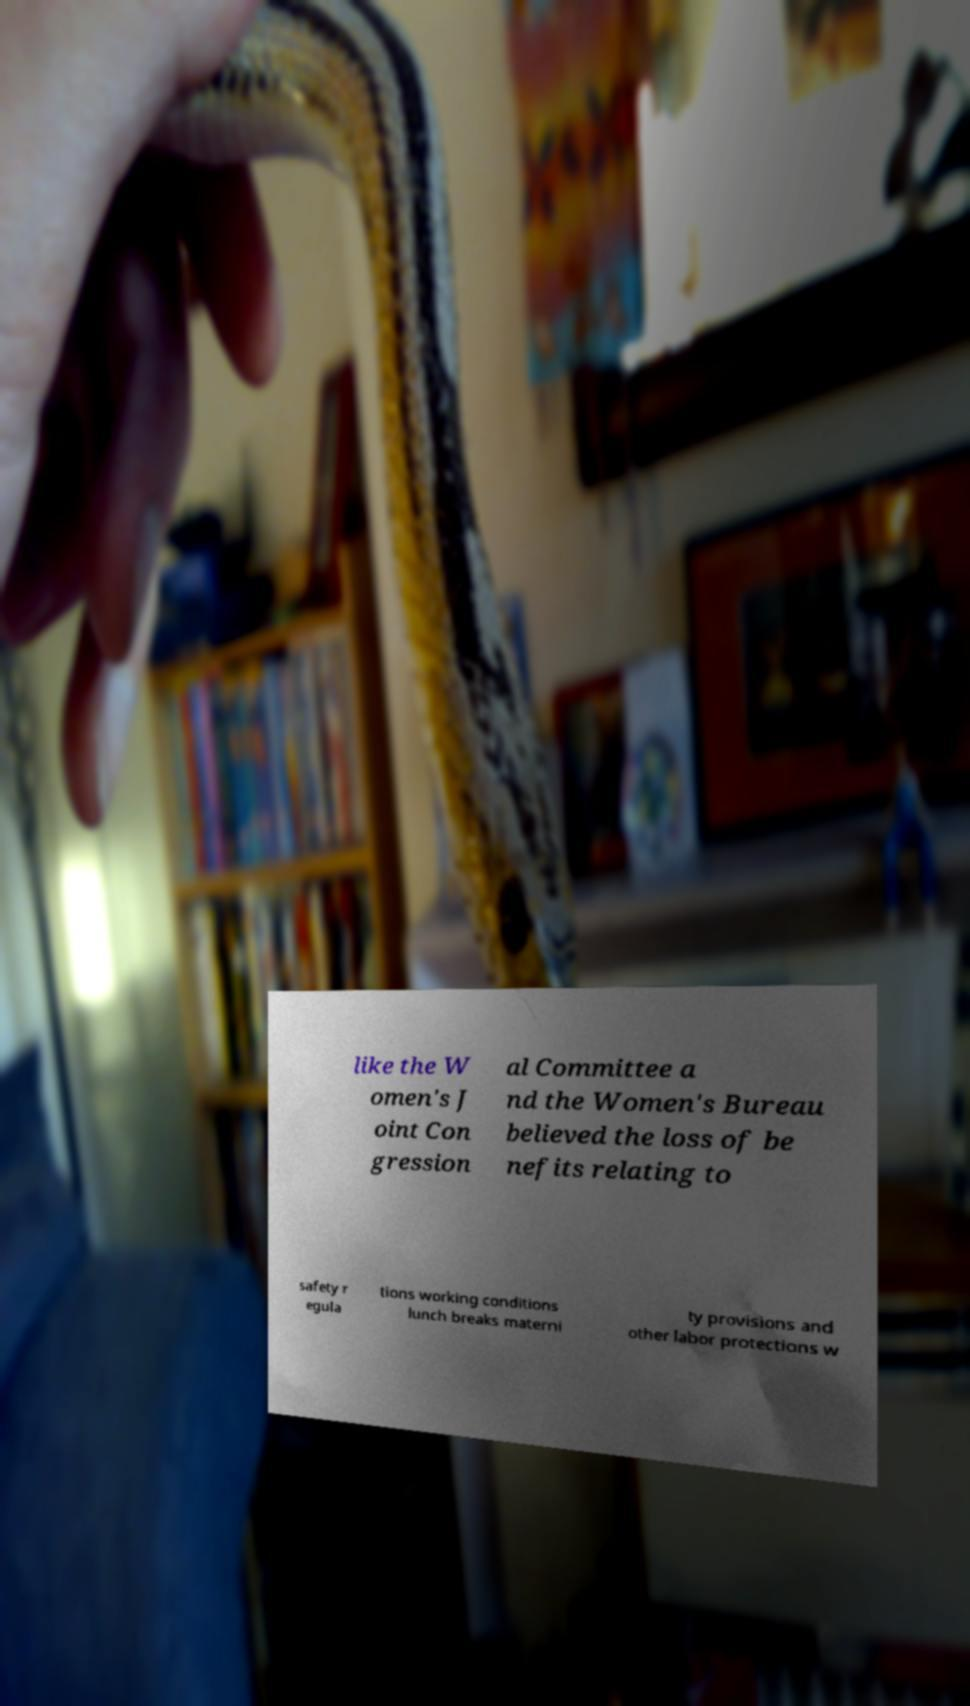Could you assist in decoding the text presented in this image and type it out clearly? like the W omen's J oint Con gression al Committee a nd the Women's Bureau believed the loss of be nefits relating to safety r egula tions working conditions lunch breaks materni ty provisions and other labor protections w 